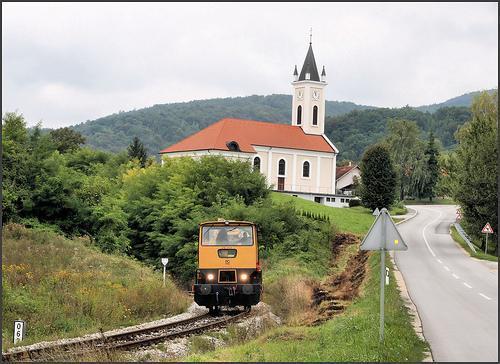How many street signs are there?
Give a very brief answer. 2. 